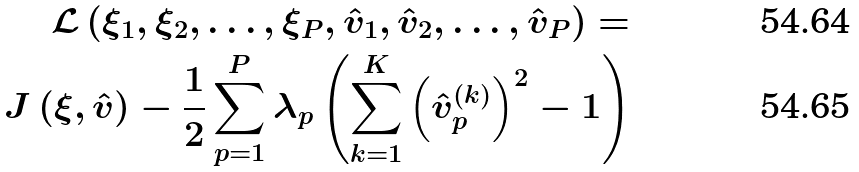<formula> <loc_0><loc_0><loc_500><loc_500>\mathcal { L } \left ( \xi _ { 1 } , \xi _ { 2 } , \dots , \xi _ { P } , \hat { v } _ { 1 } , \hat { v } _ { 2 } , \dots , \hat { v } _ { P } \right ) = \\ J \left ( \xi , \hat { v } \right ) - \frac { 1 } { 2 } \sum _ { p = 1 } ^ { P } \lambda _ { p } \left ( \sum _ { k = 1 } ^ { K } \left ( \hat { v } _ { p } ^ { ( k ) } \right ) ^ { 2 } - 1 \right )</formula> 